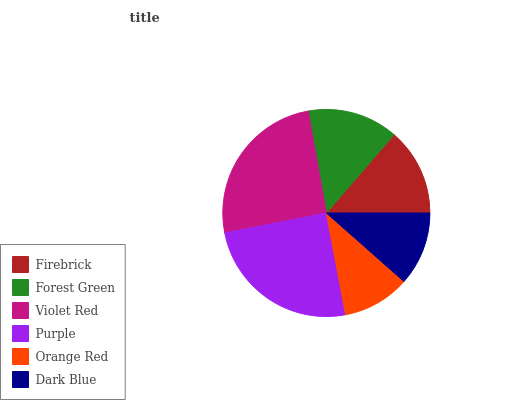Is Orange Red the minimum?
Answer yes or no. Yes. Is Violet Red the maximum?
Answer yes or no. Yes. Is Forest Green the minimum?
Answer yes or no. No. Is Forest Green the maximum?
Answer yes or no. No. Is Forest Green greater than Firebrick?
Answer yes or no. Yes. Is Firebrick less than Forest Green?
Answer yes or no. Yes. Is Firebrick greater than Forest Green?
Answer yes or no. No. Is Forest Green less than Firebrick?
Answer yes or no. No. Is Forest Green the high median?
Answer yes or no. Yes. Is Firebrick the low median?
Answer yes or no. Yes. Is Firebrick the high median?
Answer yes or no. No. Is Orange Red the low median?
Answer yes or no. No. 